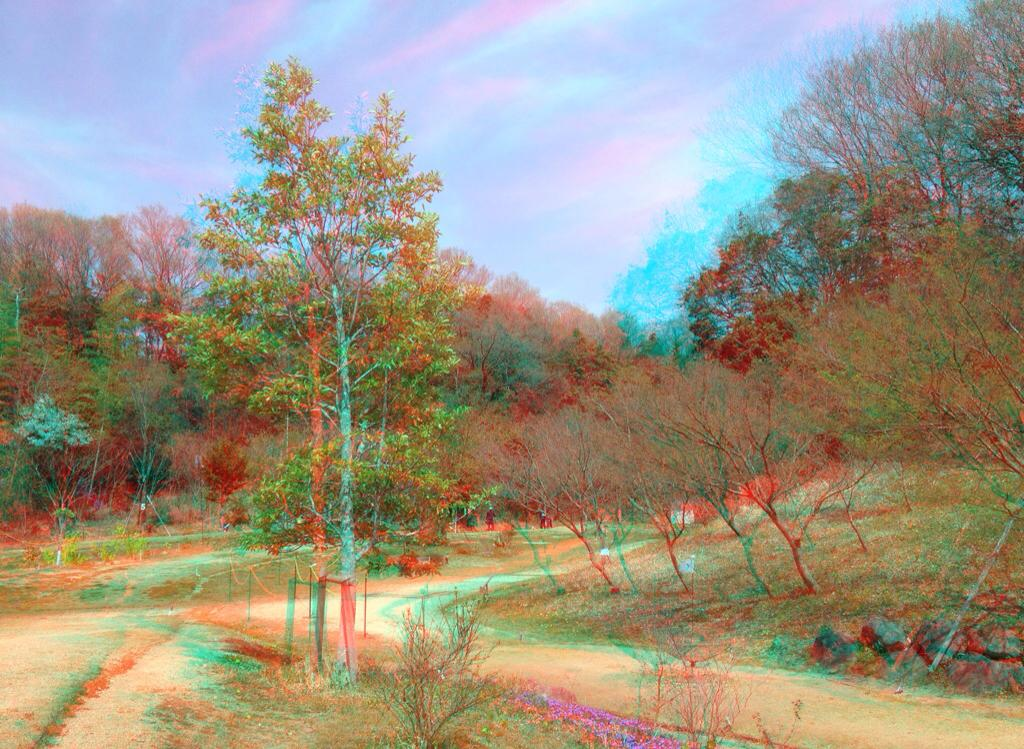What type of vegetation can be seen in the image? There are trees and plants in the image. What part of the natural environment is visible in the image? The sky is visible in the background of the image. Can you describe the vegetation in the image? The image contains trees and plants, which are both types of vegetation. What year is depicted in the image? The image does not depict a specific year; it is a photograph of trees, plants, and the sky. What type of pest can be seen in the image? There are no pests visible in the image; it features trees, plants, and the sky. 